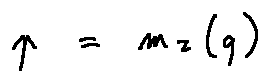<formula> <loc_0><loc_0><loc_500><loc_500>p = m _ { 2 } ( q )</formula> 